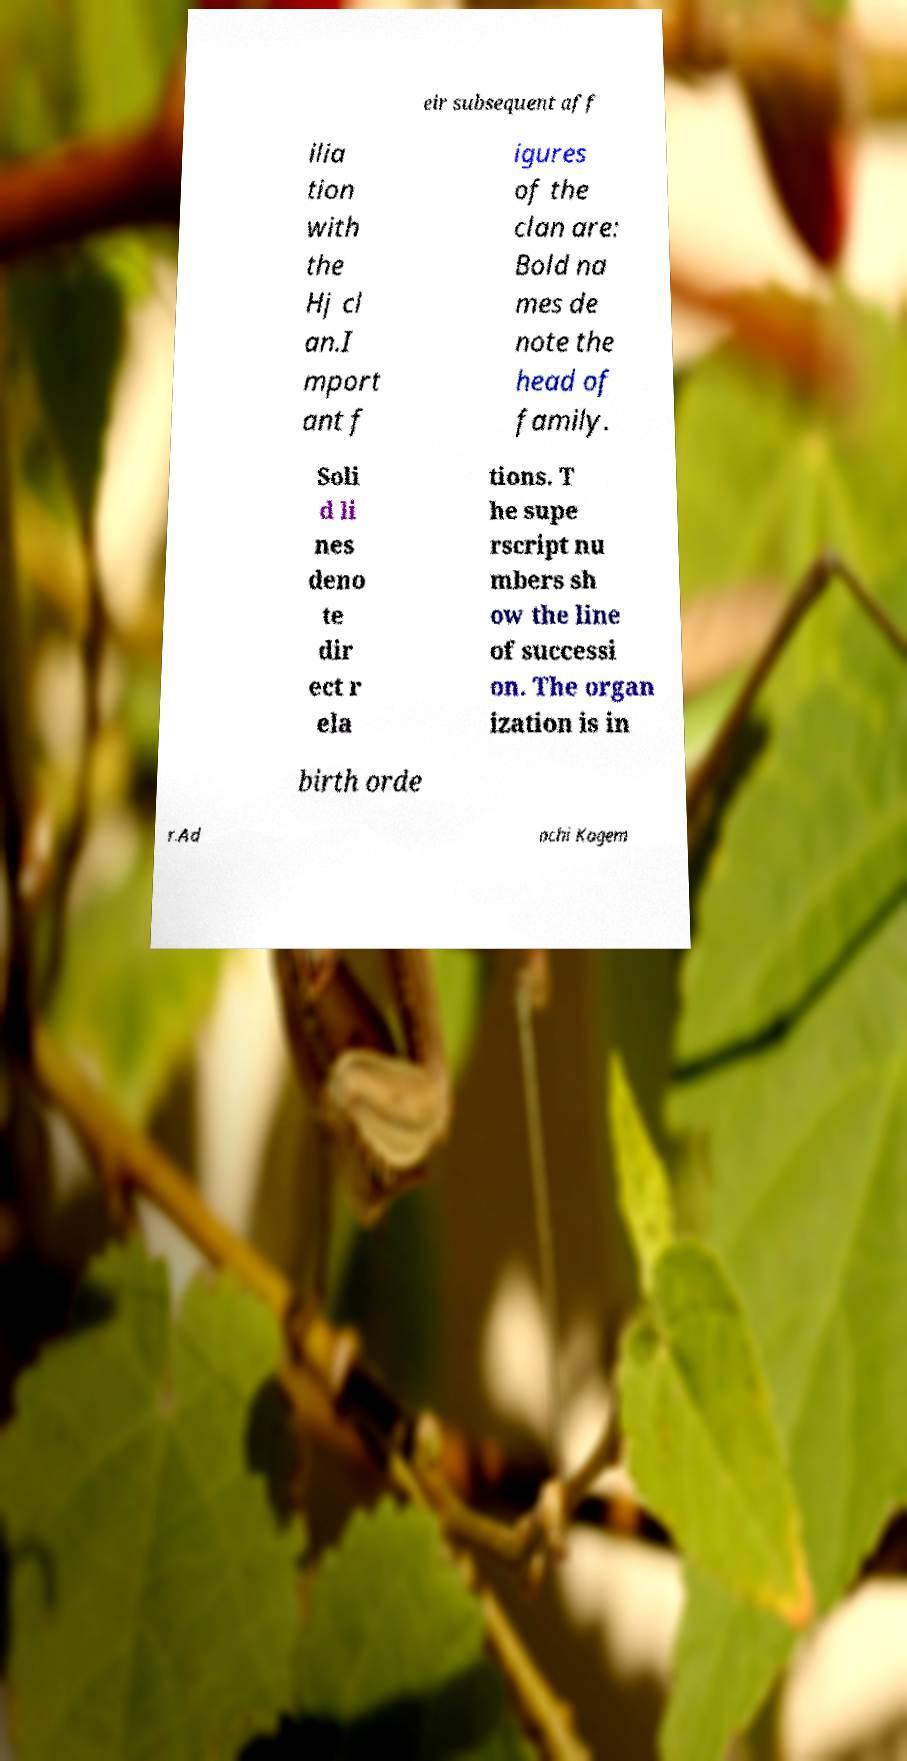For documentation purposes, I need the text within this image transcribed. Could you provide that? eir subsequent aff ilia tion with the Hj cl an.I mport ant f igures of the clan are: Bold na mes de note the head of family. Soli d li nes deno te dir ect r ela tions. T he supe rscript nu mbers sh ow the line of successi on. The organ ization is in birth orde r.Ad achi Kagem 